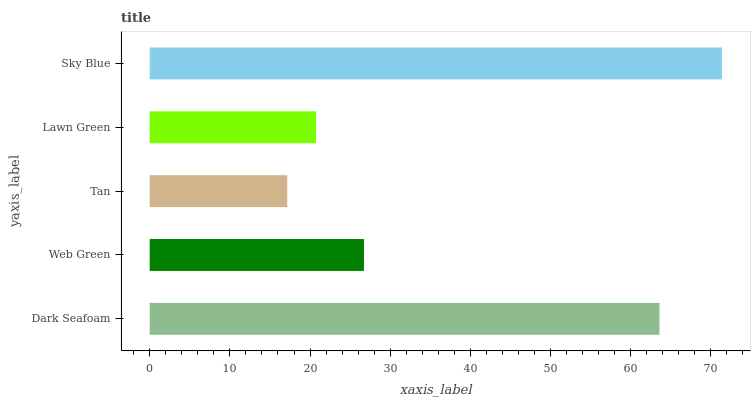Is Tan the minimum?
Answer yes or no. Yes. Is Sky Blue the maximum?
Answer yes or no. Yes. Is Web Green the minimum?
Answer yes or no. No. Is Web Green the maximum?
Answer yes or no. No. Is Dark Seafoam greater than Web Green?
Answer yes or no. Yes. Is Web Green less than Dark Seafoam?
Answer yes or no. Yes. Is Web Green greater than Dark Seafoam?
Answer yes or no. No. Is Dark Seafoam less than Web Green?
Answer yes or no. No. Is Web Green the high median?
Answer yes or no. Yes. Is Web Green the low median?
Answer yes or no. Yes. Is Tan the high median?
Answer yes or no. No. Is Sky Blue the low median?
Answer yes or no. No. 